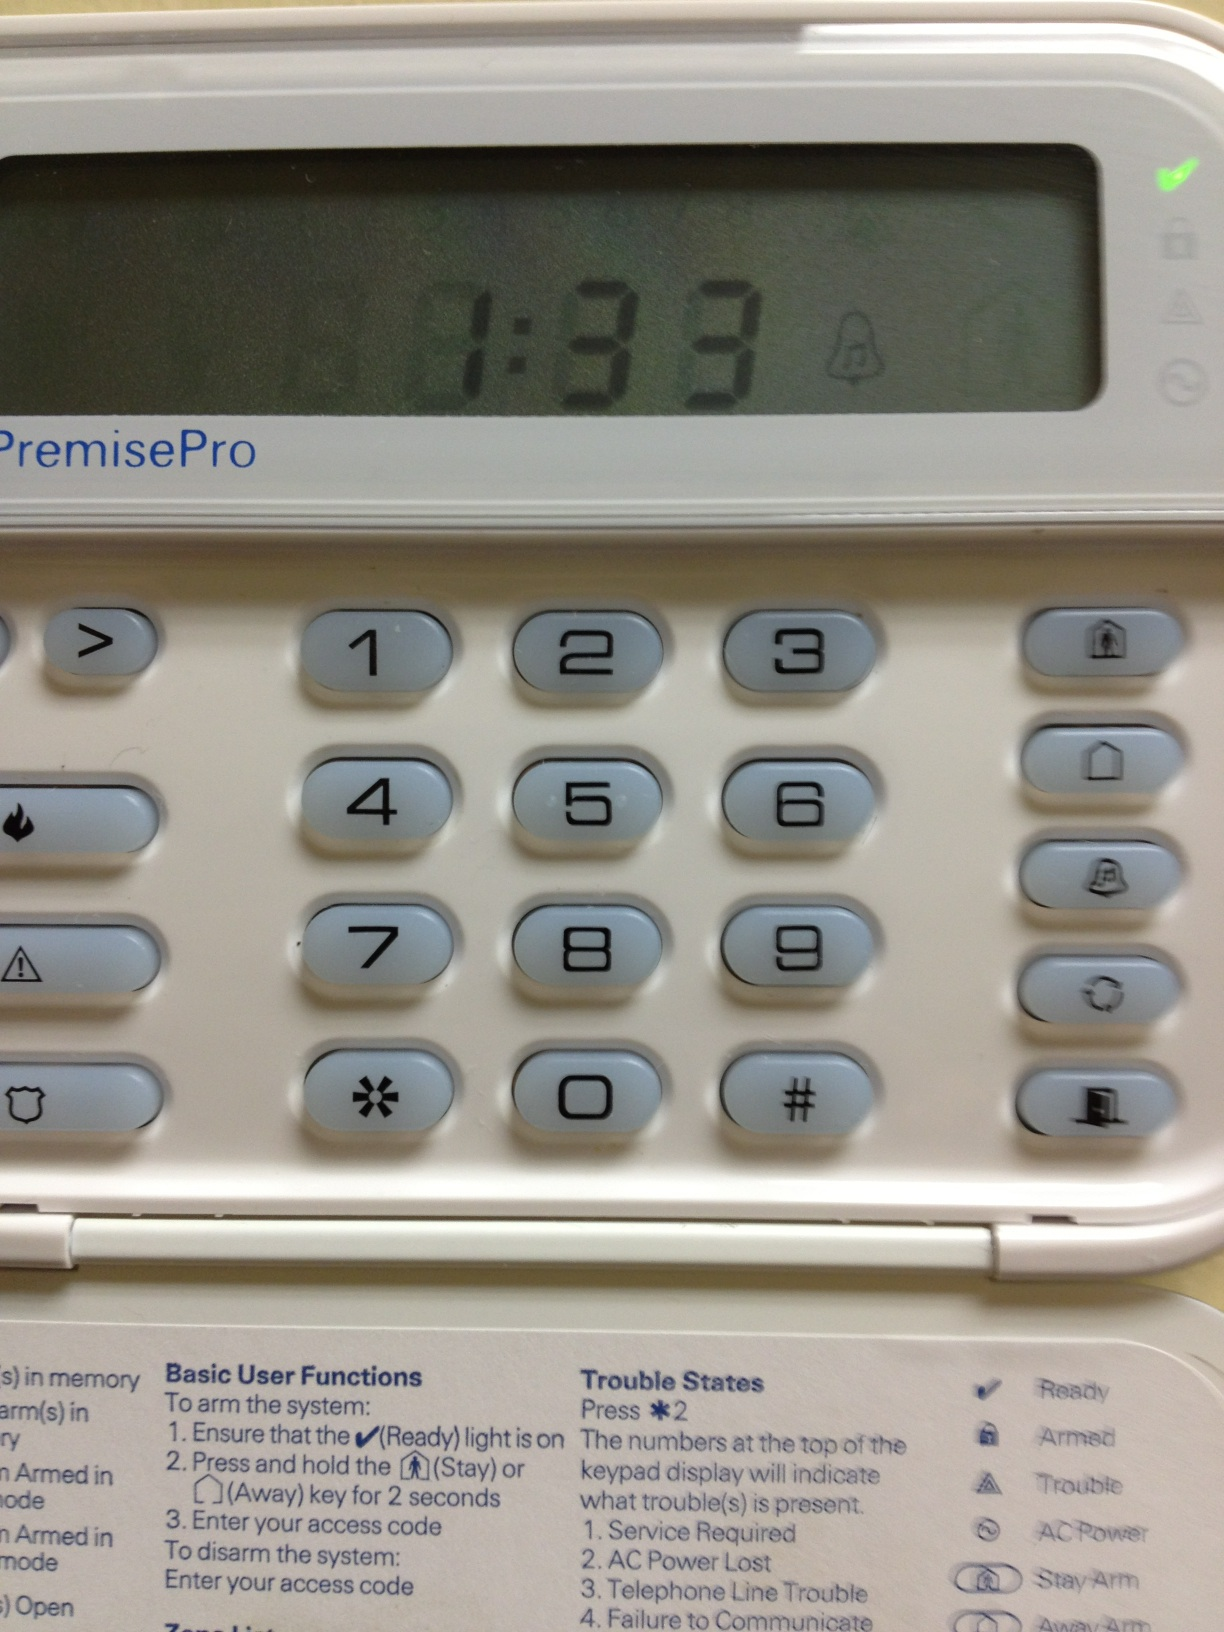What is the function of the buttons marked with a bell and a person running? The button with a bell likely serves as an alarm or panic button, while the one with a person running could be used for quick emergency exit or to set the alarm to a 'stay' or 'away' mode. 